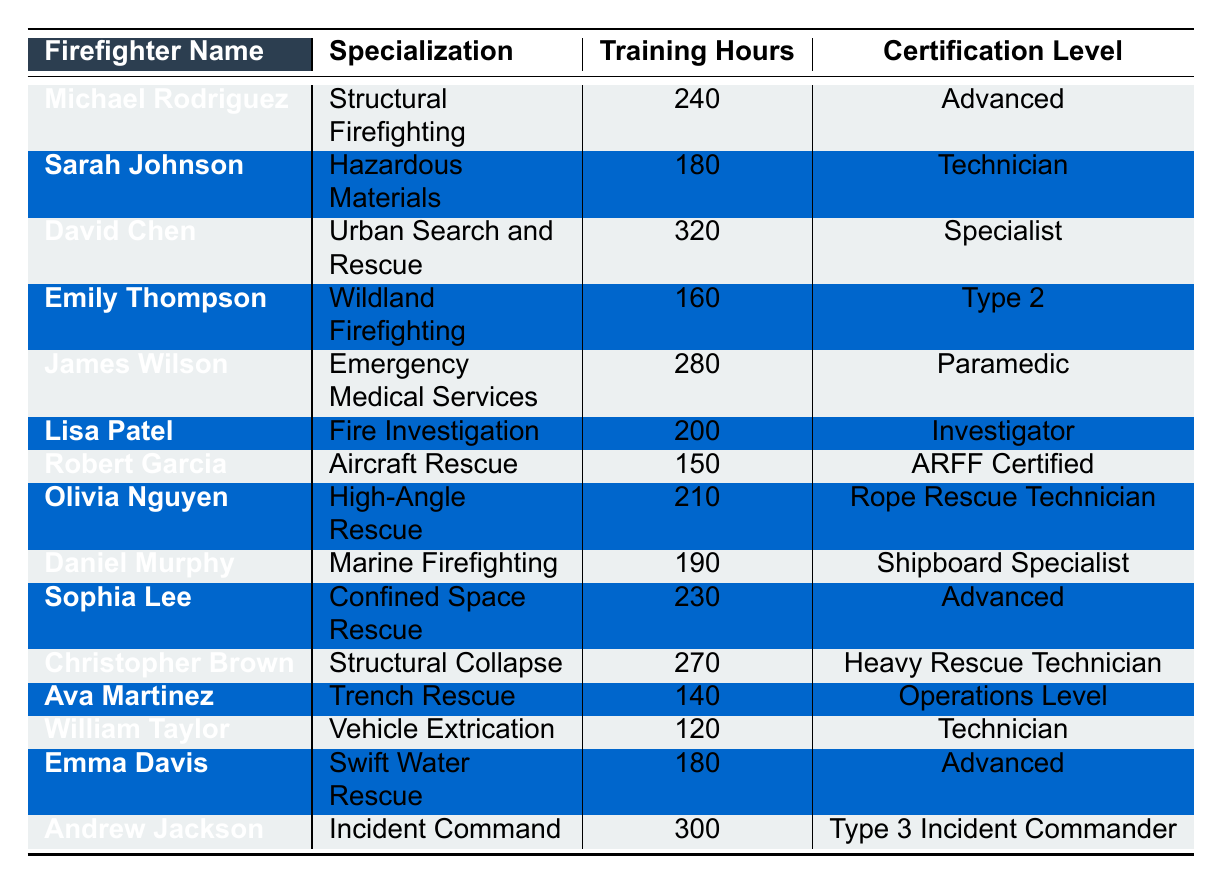What is the highest number of training hours completed by a firefighter? The highest number of training hours is found in the row for David Chen, who completed 320 hours.
Answer: 320 Which firefighter has completed the least training hours? The row for William Taylor shows he completed 120 hours, which is the lowest.
Answer: 120 How many training hours did Sarah Johnson complete? In the table, Sarah Johnson's row indicates she completed 180 hours.
Answer: 180 Is there any firefighter specialized in Vehicle Extrication who is also a Technician? Yes, William Taylor specializes in Vehicle Extrication and holds a Technician certification.
Answer: Yes What is the combined total of training hours for Emily Thompson and Ava Martinez? Emily completed 160 hours and Ava completed 140 hours, so the total is 160 + 140 = 300 hours.
Answer: 300 How many firefighters have completed over 250 hours of training? By reviewing the table, David Chen, James Wilson, and Andrew Jackson have completed over 250 hours, totaling three firefighters.
Answer: 3 What is the average number of training hours completed by firefighters specializing in Rescue operations? For High-Angle Rescue (Olivia Nguyen: 210), Confined Space Rescue (Sophia Lee: 230), and Swift Water Rescue (Emma Davis: 180), the average is (210 + 230 + 180) / 3 = 220.
Answer: 220 Which specialization has the highest number of training hours completed? David Chen in Urban Search and Rescue completed the highest at 320 hours, which is unique to his specialization.
Answer: Urban Search and Rescue What percentage of the firefighters completed more than 200 training hours? There are 15 firefighters in total. These include Michael Rodriguez, David Chen, James Wilson, Lisa Patel, Olivia Nguyen, Sophia Lee, and Christopher Brown, totaling 7 who completed over 200 hours. The percentage is (7 / 15) * 100 = 46.67%.
Answer: 46.67% Is there a firefighter specializing in Wildland Firefighting with an Advanced certification? No, Emily Thompson specializes in Wildland Firefighting but has a Type 2 certification.
Answer: No 